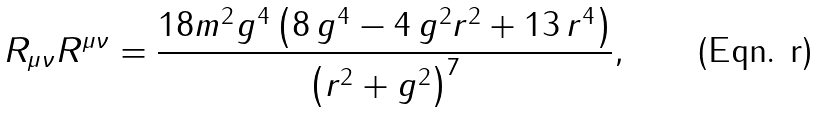<formula> <loc_0><loc_0><loc_500><loc_500>R _ { \mu \nu } R ^ { \mu \nu } = \frac { 1 8 m ^ { 2 } g ^ { 4 } \left ( 8 \, g ^ { 4 } - 4 \, g ^ { 2 } r ^ { 2 } + 1 3 \, r ^ { 4 } \right ) } { \left ( r ^ { 2 } + g ^ { 2 } \right ) ^ { 7 } } ,</formula> 